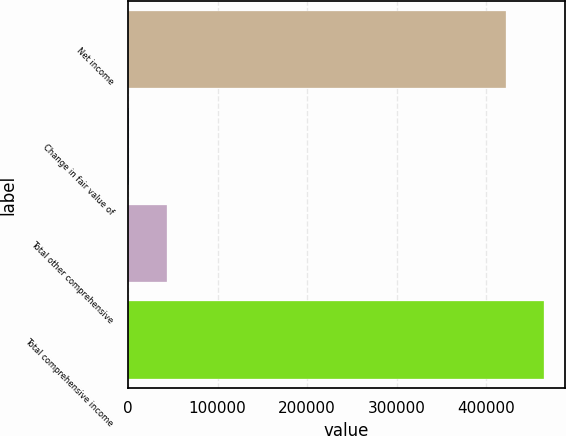Convert chart to OTSL. <chart><loc_0><loc_0><loc_500><loc_500><bar_chart><fcel>Net income<fcel>Change in fair value of<fcel>Total other comprehensive<fcel>Total comprehensive income<nl><fcel>422599<fcel>1371<fcel>43690.4<fcel>464918<nl></chart> 